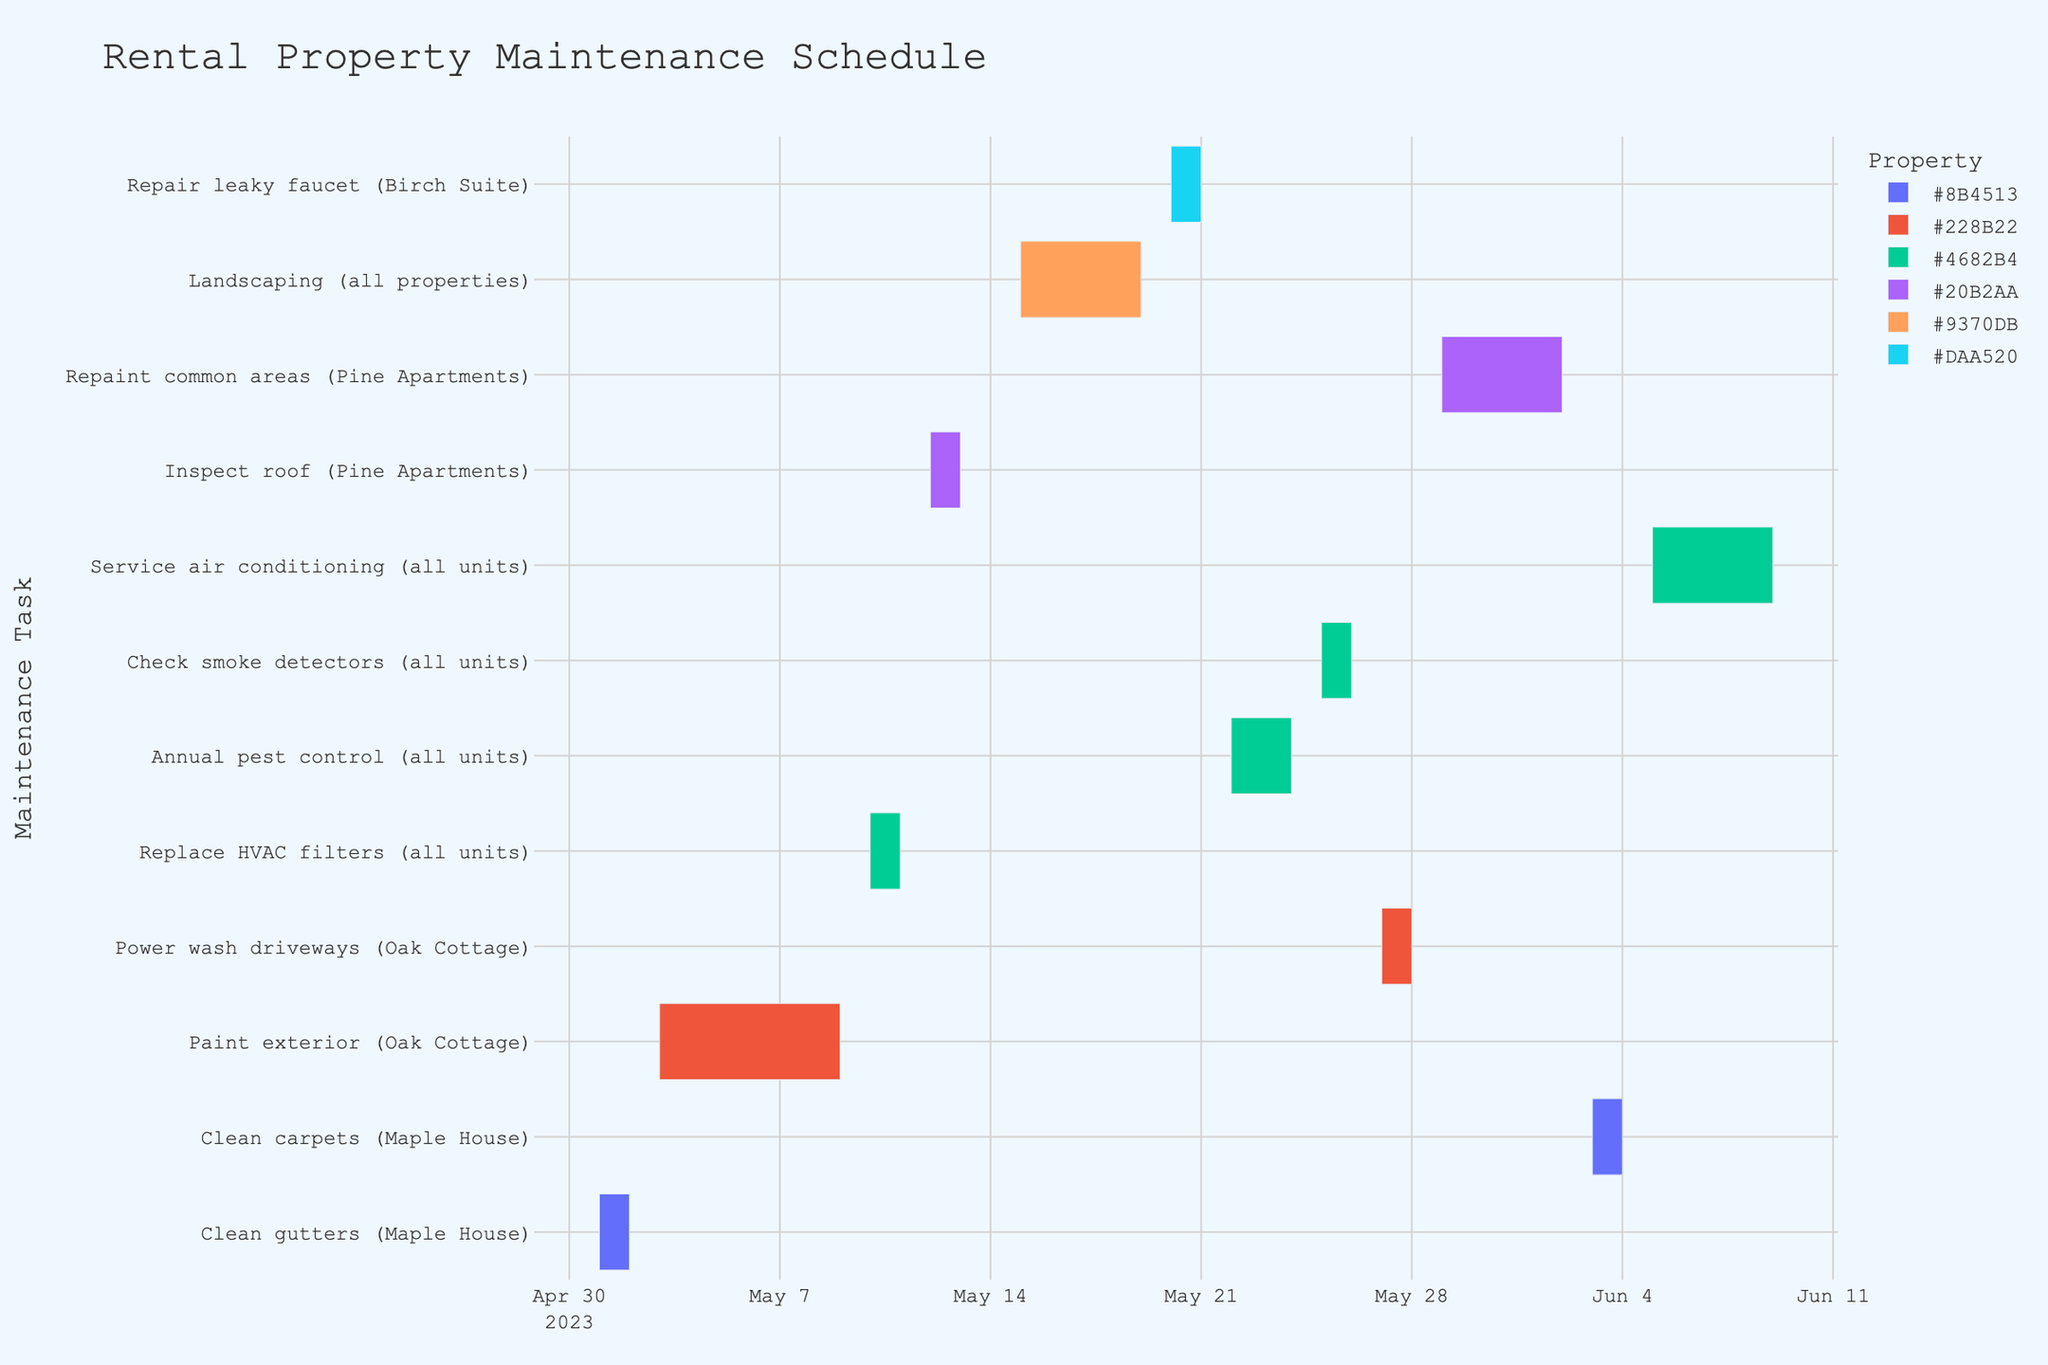What's the title of the chart? The title of the chart is located at the top of the figure and reads "Rental Property Maintenance Schedule".
Answer: Rental Property Maintenance Schedule How many tasks are scheduled for Maple House? To find the tasks for Maple House, look for tasks containing "Maple House". There are two tasks: "Clean gutters (Maple House)" and "Clean carpets (Maple House)".
Answer: 2 Which maintenance task takes the most extended period to complete? By comparing the duration of each maintenance task from start date to end date, “Repaint common areas” (Pine Apartments) takes the longest, spanning from 2023-05-29 to 2023-06-02.
Answer: Repaint common areas (Pine Apartments) What is the total duration of landscaping tasks? The "Landscaping (all properties)" task starts on 2023-05-15 and ends on 2023-05-19. The total duration is the number of days between these dates.
Answer: 5 days Which tasks share the same date range? By examining task timelines, "Check smoke detectors (all units)" and "Power wash driveways (Oak Cottage)" do not overlap directly, but "Replace HVAC filters (all units)" and "Inspect roof (Pine Apartments)" overlap partially from 2023-05-10 to 2023-05-13.
Answer: Replace HVAC filters (all units) and Inspect roof (Pine Apartments) When does service air conditioning start and end? Look at the timeline for “Service air conditioning (all units)” to find it starts on 2023-06-05 and ends on 2023-06-09.
Answer: 2023-06-05 to 2023-06-09 What's the combined duration for tasks involving Maple House? “Clean gutters (Maple House)” spans 2 days, and “Clean carpets (Maple House)” spans 2 days. Adding these gives the total duration: 2 days + 2 days = 4 days.
Answer: 4 days Which property has the most tasks scheduled? Count the tasks for each property. Maple House has 2, Oak Cottage has 2, Pine Apartments has 2, Birch Suite has 1, and all units/properties have 3 tasks. The "all units/properties" tasks apply to all properties, but individually, Maple House and Oak Cottage tie with the most tasks.
Answer: Maple House and Oak Cottage Which maintenance tasks are scheduled to occur at the end of May? Look for tasks scheduled near the end of May: "Power wash driveways (Oak Cottage)" from 2023-05-27 to 2023-05-28 and “Repaint common areas (Pine Apartments)” starting on 2023-05-29.
Answer: Power wash driveways and Repaint common areas 